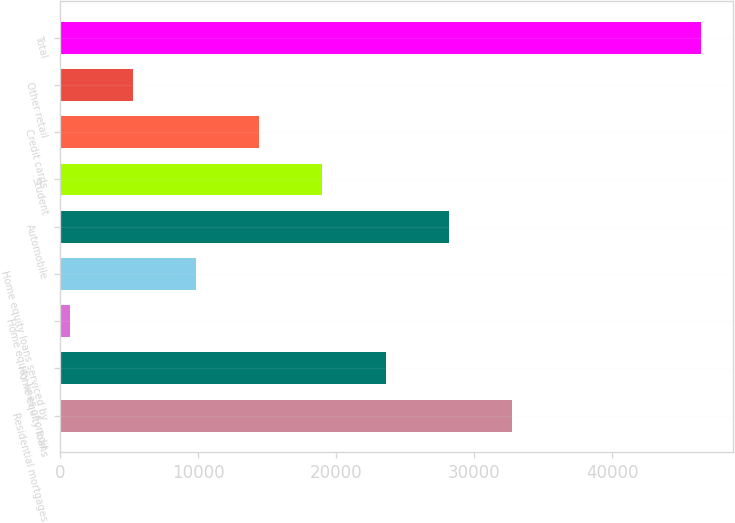Convert chart to OTSL. <chart><loc_0><loc_0><loc_500><loc_500><bar_chart><fcel>Residential mortgages<fcel>Home equity loans<fcel>Home equity lines of credit<fcel>Home equity loans serviced by<fcel>Automobile<fcel>Student<fcel>Credit cards<fcel>Other retail<fcel>Total<nl><fcel>32728.5<fcel>23571.5<fcel>679<fcel>9836<fcel>28150<fcel>18993<fcel>14414.5<fcel>5257.5<fcel>46464<nl></chart> 